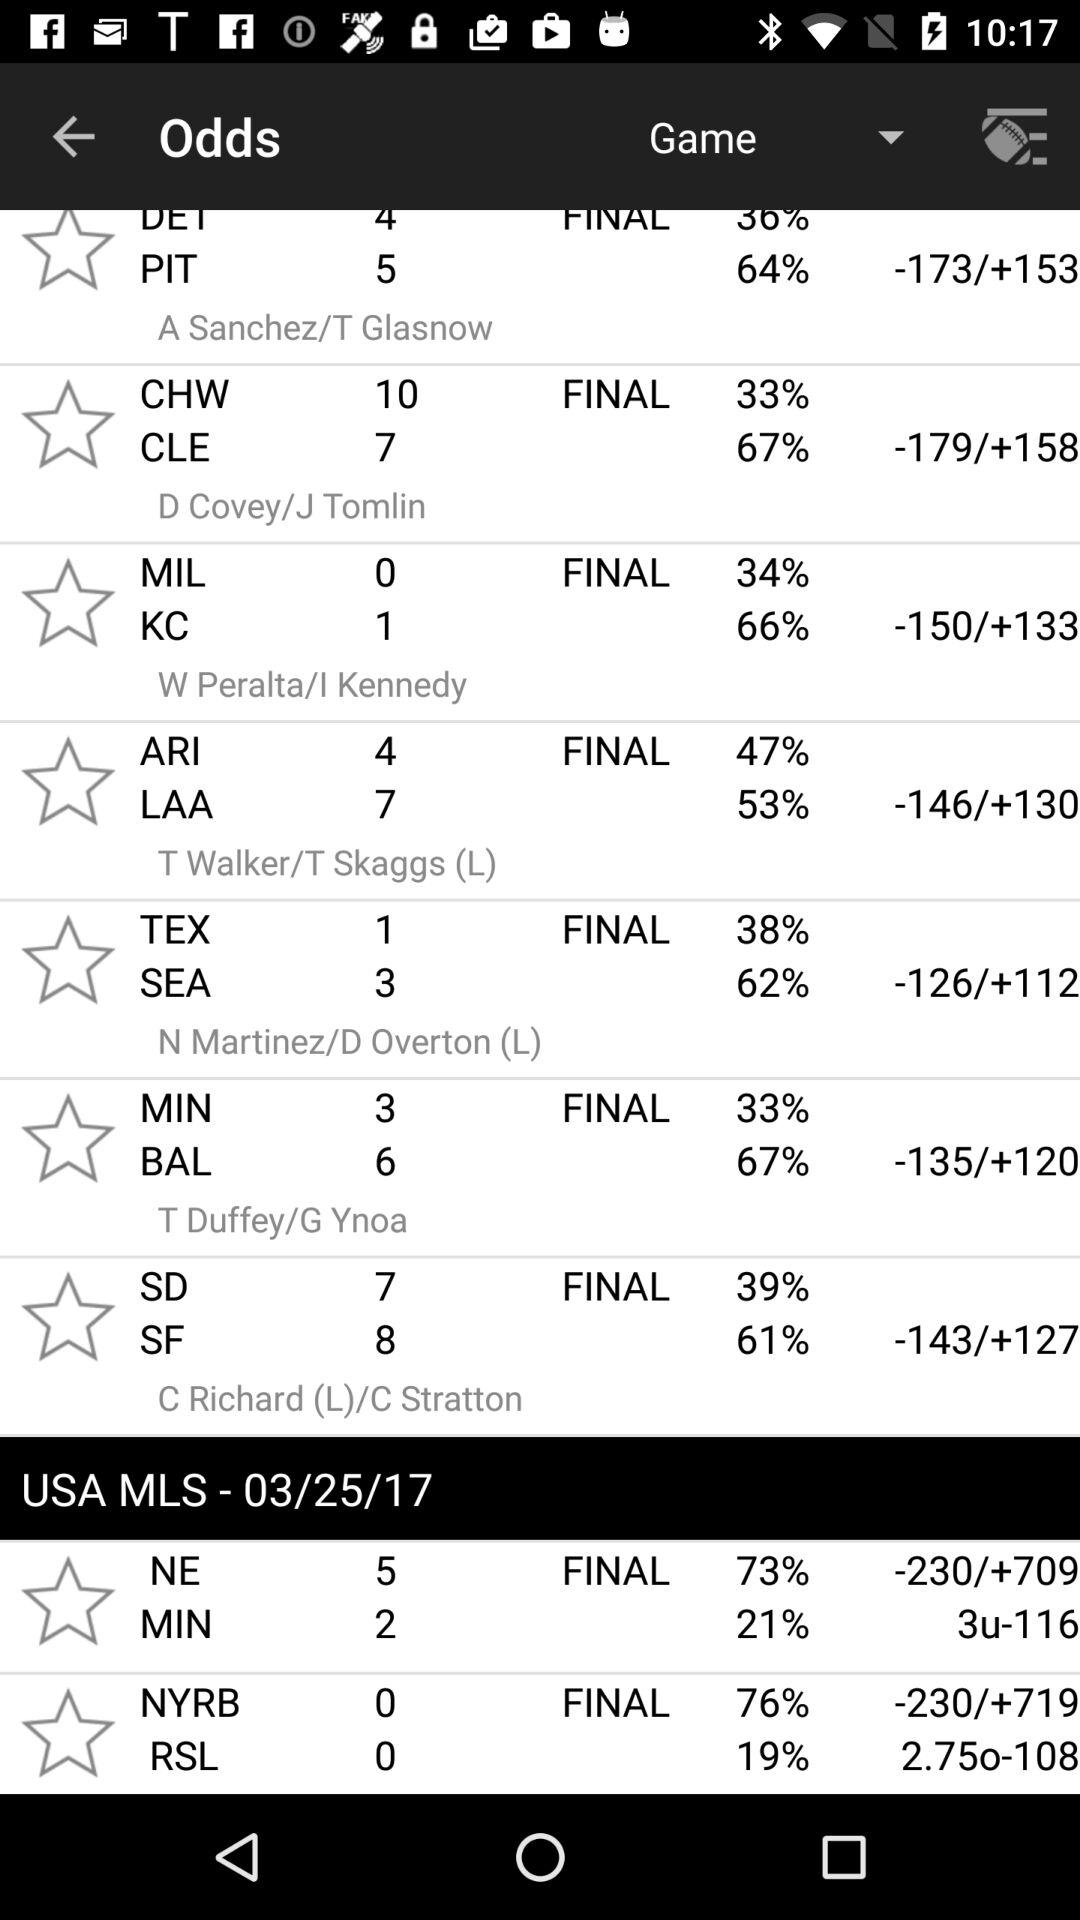What is the USA MLS match date? The date of the USA MLS matches is March 25, 2017. 